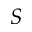Convert formula to latex. <formula><loc_0><loc_0><loc_500><loc_500>S</formula> 